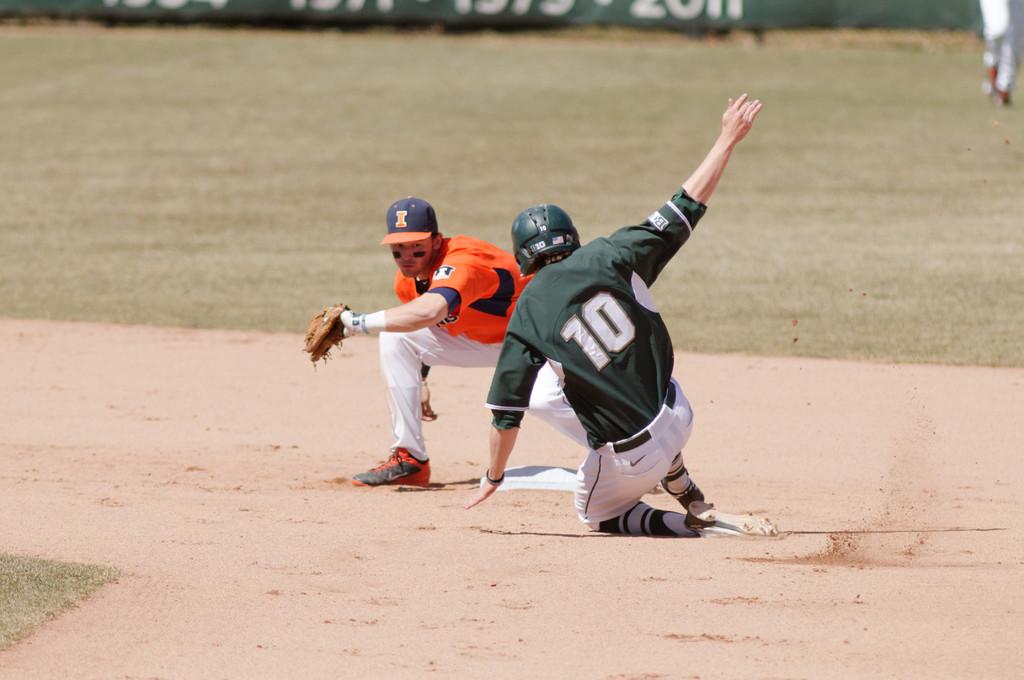What number is the baseball player sliding into base?
Offer a terse response. 10. 